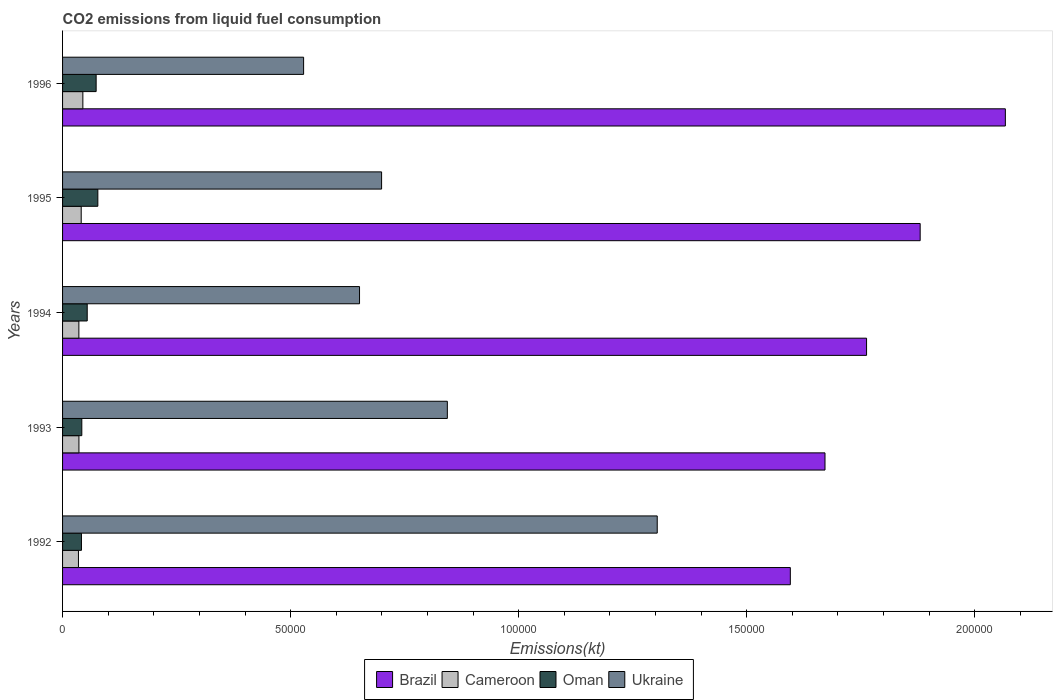How many different coloured bars are there?
Ensure brevity in your answer.  4. How many groups of bars are there?
Provide a short and direct response. 5. Are the number of bars per tick equal to the number of legend labels?
Your answer should be compact. Yes. Are the number of bars on each tick of the Y-axis equal?
Offer a terse response. Yes. In how many cases, is the number of bars for a given year not equal to the number of legend labels?
Make the answer very short. 0. What is the amount of CO2 emitted in Ukraine in 1994?
Provide a short and direct response. 6.51e+04. Across all years, what is the maximum amount of CO2 emitted in Cameroon?
Ensure brevity in your answer.  4448.07. Across all years, what is the minimum amount of CO2 emitted in Cameroon?
Your answer should be compact. 3483.65. In which year was the amount of CO2 emitted in Ukraine minimum?
Provide a short and direct response. 1996. What is the total amount of CO2 emitted in Cameroon in the graph?
Keep it short and to the point. 1.92e+04. What is the difference between the amount of CO2 emitted in Brazil in 1992 and that in 1996?
Your answer should be very brief. -4.71e+04. What is the difference between the amount of CO2 emitted in Oman in 1994 and the amount of CO2 emitted in Cameroon in 1996?
Your answer should be very brief. 957.09. What is the average amount of CO2 emitted in Cameroon per year?
Offer a very short reply. 3836.42. In the year 1993, what is the difference between the amount of CO2 emitted in Ukraine and amount of CO2 emitted in Cameroon?
Your answer should be very brief. 8.08e+04. In how many years, is the amount of CO2 emitted in Ukraine greater than 60000 kt?
Your response must be concise. 4. What is the ratio of the amount of CO2 emitted in Ukraine in 1995 to that in 1996?
Give a very brief answer. 1.32. Is the difference between the amount of CO2 emitted in Ukraine in 1994 and 1996 greater than the difference between the amount of CO2 emitted in Cameroon in 1994 and 1996?
Offer a very short reply. Yes. What is the difference between the highest and the second highest amount of CO2 emitted in Ukraine?
Make the answer very short. 4.60e+04. What is the difference between the highest and the lowest amount of CO2 emitted in Ukraine?
Offer a very short reply. 7.75e+04. In how many years, is the amount of CO2 emitted in Ukraine greater than the average amount of CO2 emitted in Ukraine taken over all years?
Give a very brief answer. 2. Is the sum of the amount of CO2 emitted in Oman in 1993 and 1995 greater than the maximum amount of CO2 emitted in Cameroon across all years?
Your response must be concise. Yes. Is it the case that in every year, the sum of the amount of CO2 emitted in Oman and amount of CO2 emitted in Cameroon is greater than the sum of amount of CO2 emitted in Ukraine and amount of CO2 emitted in Brazil?
Your answer should be compact. No. What does the 2nd bar from the top in 1992 represents?
Offer a terse response. Oman. What does the 3rd bar from the bottom in 1994 represents?
Your answer should be very brief. Oman. Is it the case that in every year, the sum of the amount of CO2 emitted in Oman and amount of CO2 emitted in Ukraine is greater than the amount of CO2 emitted in Cameroon?
Offer a terse response. Yes. How many years are there in the graph?
Your answer should be compact. 5. What is the difference between two consecutive major ticks on the X-axis?
Provide a short and direct response. 5.00e+04. Are the values on the major ticks of X-axis written in scientific E-notation?
Your answer should be compact. No. Does the graph contain any zero values?
Offer a terse response. No. Does the graph contain grids?
Your answer should be compact. No. Where does the legend appear in the graph?
Offer a very short reply. Bottom center. How are the legend labels stacked?
Provide a short and direct response. Horizontal. What is the title of the graph?
Give a very brief answer. CO2 emissions from liquid fuel consumption. Does "Chile" appear as one of the legend labels in the graph?
Offer a terse response. No. What is the label or title of the X-axis?
Offer a very short reply. Emissions(kt). What is the Emissions(kt) of Brazil in 1992?
Provide a succinct answer. 1.60e+05. What is the Emissions(kt) of Cameroon in 1992?
Give a very brief answer. 3483.65. What is the Emissions(kt) of Oman in 1992?
Offer a very short reply. 4140.04. What is the Emissions(kt) of Ukraine in 1992?
Provide a short and direct response. 1.30e+05. What is the Emissions(kt) of Brazil in 1993?
Provide a succinct answer. 1.67e+05. What is the Emissions(kt) in Cameroon in 1993?
Your response must be concise. 3589.99. What is the Emissions(kt) of Oman in 1993?
Provide a succinct answer. 4220.72. What is the Emissions(kt) of Ukraine in 1993?
Your answer should be compact. 8.44e+04. What is the Emissions(kt) in Brazil in 1994?
Keep it short and to the point. 1.76e+05. What is the Emissions(kt) in Cameroon in 1994?
Your answer should be very brief. 3575.32. What is the Emissions(kt) of Oman in 1994?
Offer a very short reply. 5405.16. What is the Emissions(kt) in Ukraine in 1994?
Ensure brevity in your answer.  6.51e+04. What is the Emissions(kt) in Brazil in 1995?
Your response must be concise. 1.88e+05. What is the Emissions(kt) in Cameroon in 1995?
Keep it short and to the point. 4085.04. What is the Emissions(kt) of Oman in 1995?
Provide a short and direct response. 7733.7. What is the Emissions(kt) of Ukraine in 1995?
Offer a terse response. 7.00e+04. What is the Emissions(kt) of Brazil in 1996?
Give a very brief answer. 2.07e+05. What is the Emissions(kt) in Cameroon in 1996?
Ensure brevity in your answer.  4448.07. What is the Emissions(kt) of Oman in 1996?
Offer a very short reply. 7363.34. What is the Emissions(kt) in Ukraine in 1996?
Your answer should be compact. 5.29e+04. Across all years, what is the maximum Emissions(kt) of Brazil?
Offer a very short reply. 2.07e+05. Across all years, what is the maximum Emissions(kt) in Cameroon?
Your response must be concise. 4448.07. Across all years, what is the maximum Emissions(kt) in Oman?
Give a very brief answer. 7733.7. Across all years, what is the maximum Emissions(kt) in Ukraine?
Give a very brief answer. 1.30e+05. Across all years, what is the minimum Emissions(kt) of Brazil?
Provide a short and direct response. 1.60e+05. Across all years, what is the minimum Emissions(kt) of Cameroon?
Offer a very short reply. 3483.65. Across all years, what is the minimum Emissions(kt) of Oman?
Keep it short and to the point. 4140.04. Across all years, what is the minimum Emissions(kt) in Ukraine?
Provide a succinct answer. 5.29e+04. What is the total Emissions(kt) in Brazil in the graph?
Provide a succinct answer. 8.98e+05. What is the total Emissions(kt) in Cameroon in the graph?
Provide a succinct answer. 1.92e+04. What is the total Emissions(kt) of Oman in the graph?
Make the answer very short. 2.89e+04. What is the total Emissions(kt) in Ukraine in the graph?
Offer a terse response. 4.03e+05. What is the difference between the Emissions(kt) in Brazil in 1992 and that in 1993?
Your response must be concise. -7601.69. What is the difference between the Emissions(kt) in Cameroon in 1992 and that in 1993?
Your answer should be very brief. -106.34. What is the difference between the Emissions(kt) of Oman in 1992 and that in 1993?
Make the answer very short. -80.67. What is the difference between the Emissions(kt) of Ukraine in 1992 and that in 1993?
Offer a very short reply. 4.60e+04. What is the difference between the Emissions(kt) in Brazil in 1992 and that in 1994?
Your answer should be compact. -1.67e+04. What is the difference between the Emissions(kt) of Cameroon in 1992 and that in 1994?
Ensure brevity in your answer.  -91.67. What is the difference between the Emissions(kt) in Oman in 1992 and that in 1994?
Provide a succinct answer. -1265.12. What is the difference between the Emissions(kt) in Ukraine in 1992 and that in 1994?
Keep it short and to the point. 6.53e+04. What is the difference between the Emissions(kt) of Brazil in 1992 and that in 1995?
Give a very brief answer. -2.85e+04. What is the difference between the Emissions(kt) of Cameroon in 1992 and that in 1995?
Offer a very short reply. -601.39. What is the difference between the Emissions(kt) in Oman in 1992 and that in 1995?
Offer a terse response. -3593.66. What is the difference between the Emissions(kt) in Ukraine in 1992 and that in 1995?
Your response must be concise. 6.04e+04. What is the difference between the Emissions(kt) in Brazil in 1992 and that in 1996?
Offer a terse response. -4.71e+04. What is the difference between the Emissions(kt) in Cameroon in 1992 and that in 1996?
Ensure brevity in your answer.  -964.42. What is the difference between the Emissions(kt) of Oman in 1992 and that in 1996?
Keep it short and to the point. -3223.29. What is the difference between the Emissions(kt) of Ukraine in 1992 and that in 1996?
Keep it short and to the point. 7.75e+04. What is the difference between the Emissions(kt) in Brazil in 1993 and that in 1994?
Your answer should be compact. -9112.5. What is the difference between the Emissions(kt) of Cameroon in 1993 and that in 1994?
Provide a short and direct response. 14.67. What is the difference between the Emissions(kt) of Oman in 1993 and that in 1994?
Provide a succinct answer. -1184.44. What is the difference between the Emissions(kt) of Ukraine in 1993 and that in 1994?
Your response must be concise. 1.93e+04. What is the difference between the Emissions(kt) of Brazil in 1993 and that in 1995?
Keep it short and to the point. -2.09e+04. What is the difference between the Emissions(kt) of Cameroon in 1993 and that in 1995?
Your answer should be very brief. -495.05. What is the difference between the Emissions(kt) in Oman in 1993 and that in 1995?
Your answer should be very brief. -3512.99. What is the difference between the Emissions(kt) of Ukraine in 1993 and that in 1995?
Give a very brief answer. 1.44e+04. What is the difference between the Emissions(kt) of Brazil in 1993 and that in 1996?
Provide a succinct answer. -3.95e+04. What is the difference between the Emissions(kt) in Cameroon in 1993 and that in 1996?
Your answer should be very brief. -858.08. What is the difference between the Emissions(kt) in Oman in 1993 and that in 1996?
Offer a terse response. -3142.62. What is the difference between the Emissions(kt) in Ukraine in 1993 and that in 1996?
Offer a very short reply. 3.15e+04. What is the difference between the Emissions(kt) in Brazil in 1994 and that in 1995?
Your response must be concise. -1.18e+04. What is the difference between the Emissions(kt) in Cameroon in 1994 and that in 1995?
Offer a very short reply. -509.71. What is the difference between the Emissions(kt) of Oman in 1994 and that in 1995?
Make the answer very short. -2328.55. What is the difference between the Emissions(kt) of Ukraine in 1994 and that in 1995?
Make the answer very short. -4836.77. What is the difference between the Emissions(kt) of Brazil in 1994 and that in 1996?
Ensure brevity in your answer.  -3.04e+04. What is the difference between the Emissions(kt) in Cameroon in 1994 and that in 1996?
Give a very brief answer. -872.75. What is the difference between the Emissions(kt) of Oman in 1994 and that in 1996?
Keep it short and to the point. -1958.18. What is the difference between the Emissions(kt) in Ukraine in 1994 and that in 1996?
Your response must be concise. 1.23e+04. What is the difference between the Emissions(kt) in Brazil in 1995 and that in 1996?
Give a very brief answer. -1.87e+04. What is the difference between the Emissions(kt) of Cameroon in 1995 and that in 1996?
Provide a short and direct response. -363.03. What is the difference between the Emissions(kt) in Oman in 1995 and that in 1996?
Keep it short and to the point. 370.37. What is the difference between the Emissions(kt) of Ukraine in 1995 and that in 1996?
Provide a short and direct response. 1.71e+04. What is the difference between the Emissions(kt) of Brazil in 1992 and the Emissions(kt) of Cameroon in 1993?
Your answer should be compact. 1.56e+05. What is the difference between the Emissions(kt) in Brazil in 1992 and the Emissions(kt) in Oman in 1993?
Provide a short and direct response. 1.55e+05. What is the difference between the Emissions(kt) of Brazil in 1992 and the Emissions(kt) of Ukraine in 1993?
Your answer should be very brief. 7.52e+04. What is the difference between the Emissions(kt) of Cameroon in 1992 and the Emissions(kt) of Oman in 1993?
Keep it short and to the point. -737.07. What is the difference between the Emissions(kt) in Cameroon in 1992 and the Emissions(kt) in Ukraine in 1993?
Offer a terse response. -8.09e+04. What is the difference between the Emissions(kt) in Oman in 1992 and the Emissions(kt) in Ukraine in 1993?
Provide a short and direct response. -8.02e+04. What is the difference between the Emissions(kt) of Brazil in 1992 and the Emissions(kt) of Cameroon in 1994?
Your response must be concise. 1.56e+05. What is the difference between the Emissions(kt) of Brazil in 1992 and the Emissions(kt) of Oman in 1994?
Offer a very short reply. 1.54e+05. What is the difference between the Emissions(kt) of Brazil in 1992 and the Emissions(kt) of Ukraine in 1994?
Make the answer very short. 9.45e+04. What is the difference between the Emissions(kt) in Cameroon in 1992 and the Emissions(kt) in Oman in 1994?
Provide a short and direct response. -1921.51. What is the difference between the Emissions(kt) of Cameroon in 1992 and the Emissions(kt) of Ukraine in 1994?
Provide a succinct answer. -6.16e+04. What is the difference between the Emissions(kt) of Oman in 1992 and the Emissions(kt) of Ukraine in 1994?
Provide a succinct answer. -6.10e+04. What is the difference between the Emissions(kt) of Brazil in 1992 and the Emissions(kt) of Cameroon in 1995?
Offer a terse response. 1.55e+05. What is the difference between the Emissions(kt) of Brazil in 1992 and the Emissions(kt) of Oman in 1995?
Offer a very short reply. 1.52e+05. What is the difference between the Emissions(kt) of Brazil in 1992 and the Emissions(kt) of Ukraine in 1995?
Provide a short and direct response. 8.96e+04. What is the difference between the Emissions(kt) in Cameroon in 1992 and the Emissions(kt) in Oman in 1995?
Offer a terse response. -4250.05. What is the difference between the Emissions(kt) in Cameroon in 1992 and the Emissions(kt) in Ukraine in 1995?
Offer a very short reply. -6.65e+04. What is the difference between the Emissions(kt) of Oman in 1992 and the Emissions(kt) of Ukraine in 1995?
Keep it short and to the point. -6.58e+04. What is the difference between the Emissions(kt) in Brazil in 1992 and the Emissions(kt) in Cameroon in 1996?
Offer a terse response. 1.55e+05. What is the difference between the Emissions(kt) of Brazil in 1992 and the Emissions(kt) of Oman in 1996?
Make the answer very short. 1.52e+05. What is the difference between the Emissions(kt) of Brazil in 1992 and the Emissions(kt) of Ukraine in 1996?
Offer a terse response. 1.07e+05. What is the difference between the Emissions(kt) in Cameroon in 1992 and the Emissions(kt) in Oman in 1996?
Your response must be concise. -3879.69. What is the difference between the Emissions(kt) in Cameroon in 1992 and the Emissions(kt) in Ukraine in 1996?
Your answer should be very brief. -4.94e+04. What is the difference between the Emissions(kt) in Oman in 1992 and the Emissions(kt) in Ukraine in 1996?
Ensure brevity in your answer.  -4.87e+04. What is the difference between the Emissions(kt) of Brazil in 1993 and the Emissions(kt) of Cameroon in 1994?
Offer a very short reply. 1.64e+05. What is the difference between the Emissions(kt) of Brazil in 1993 and the Emissions(kt) of Oman in 1994?
Offer a very short reply. 1.62e+05. What is the difference between the Emissions(kt) in Brazil in 1993 and the Emissions(kt) in Ukraine in 1994?
Offer a very short reply. 1.02e+05. What is the difference between the Emissions(kt) of Cameroon in 1993 and the Emissions(kt) of Oman in 1994?
Your answer should be very brief. -1815.16. What is the difference between the Emissions(kt) in Cameroon in 1993 and the Emissions(kt) in Ukraine in 1994?
Offer a very short reply. -6.15e+04. What is the difference between the Emissions(kt) of Oman in 1993 and the Emissions(kt) of Ukraine in 1994?
Ensure brevity in your answer.  -6.09e+04. What is the difference between the Emissions(kt) in Brazil in 1993 and the Emissions(kt) in Cameroon in 1995?
Give a very brief answer. 1.63e+05. What is the difference between the Emissions(kt) in Brazil in 1993 and the Emissions(kt) in Oman in 1995?
Keep it short and to the point. 1.59e+05. What is the difference between the Emissions(kt) of Brazil in 1993 and the Emissions(kt) of Ukraine in 1995?
Keep it short and to the point. 9.72e+04. What is the difference between the Emissions(kt) of Cameroon in 1993 and the Emissions(kt) of Oman in 1995?
Provide a succinct answer. -4143.71. What is the difference between the Emissions(kt) of Cameroon in 1993 and the Emissions(kt) of Ukraine in 1995?
Make the answer very short. -6.64e+04. What is the difference between the Emissions(kt) of Oman in 1993 and the Emissions(kt) of Ukraine in 1995?
Give a very brief answer. -6.57e+04. What is the difference between the Emissions(kt) in Brazil in 1993 and the Emissions(kt) in Cameroon in 1996?
Make the answer very short. 1.63e+05. What is the difference between the Emissions(kt) in Brazil in 1993 and the Emissions(kt) in Oman in 1996?
Keep it short and to the point. 1.60e+05. What is the difference between the Emissions(kt) in Brazil in 1993 and the Emissions(kt) in Ukraine in 1996?
Make the answer very short. 1.14e+05. What is the difference between the Emissions(kt) in Cameroon in 1993 and the Emissions(kt) in Oman in 1996?
Offer a terse response. -3773.34. What is the difference between the Emissions(kt) in Cameroon in 1993 and the Emissions(kt) in Ukraine in 1996?
Your answer should be compact. -4.93e+04. What is the difference between the Emissions(kt) in Oman in 1993 and the Emissions(kt) in Ukraine in 1996?
Your response must be concise. -4.86e+04. What is the difference between the Emissions(kt) of Brazil in 1994 and the Emissions(kt) of Cameroon in 1995?
Your response must be concise. 1.72e+05. What is the difference between the Emissions(kt) of Brazil in 1994 and the Emissions(kt) of Oman in 1995?
Your answer should be very brief. 1.69e+05. What is the difference between the Emissions(kt) of Brazil in 1994 and the Emissions(kt) of Ukraine in 1995?
Make the answer very short. 1.06e+05. What is the difference between the Emissions(kt) in Cameroon in 1994 and the Emissions(kt) in Oman in 1995?
Give a very brief answer. -4158.38. What is the difference between the Emissions(kt) in Cameroon in 1994 and the Emissions(kt) in Ukraine in 1995?
Your answer should be compact. -6.64e+04. What is the difference between the Emissions(kt) in Oman in 1994 and the Emissions(kt) in Ukraine in 1995?
Make the answer very short. -6.45e+04. What is the difference between the Emissions(kt) of Brazil in 1994 and the Emissions(kt) of Cameroon in 1996?
Offer a terse response. 1.72e+05. What is the difference between the Emissions(kt) of Brazil in 1994 and the Emissions(kt) of Oman in 1996?
Offer a very short reply. 1.69e+05. What is the difference between the Emissions(kt) of Brazil in 1994 and the Emissions(kt) of Ukraine in 1996?
Ensure brevity in your answer.  1.23e+05. What is the difference between the Emissions(kt) of Cameroon in 1994 and the Emissions(kt) of Oman in 1996?
Your answer should be very brief. -3788.01. What is the difference between the Emissions(kt) of Cameroon in 1994 and the Emissions(kt) of Ukraine in 1996?
Your answer should be very brief. -4.93e+04. What is the difference between the Emissions(kt) in Oman in 1994 and the Emissions(kt) in Ukraine in 1996?
Provide a short and direct response. -4.74e+04. What is the difference between the Emissions(kt) of Brazil in 1995 and the Emissions(kt) of Cameroon in 1996?
Offer a terse response. 1.84e+05. What is the difference between the Emissions(kt) of Brazil in 1995 and the Emissions(kt) of Oman in 1996?
Keep it short and to the point. 1.81e+05. What is the difference between the Emissions(kt) in Brazil in 1995 and the Emissions(kt) in Ukraine in 1996?
Give a very brief answer. 1.35e+05. What is the difference between the Emissions(kt) in Cameroon in 1995 and the Emissions(kt) in Oman in 1996?
Ensure brevity in your answer.  -3278.3. What is the difference between the Emissions(kt) of Cameroon in 1995 and the Emissions(kt) of Ukraine in 1996?
Offer a very short reply. -4.88e+04. What is the difference between the Emissions(kt) of Oman in 1995 and the Emissions(kt) of Ukraine in 1996?
Make the answer very short. -4.51e+04. What is the average Emissions(kt) in Brazil per year?
Your answer should be compact. 1.80e+05. What is the average Emissions(kt) in Cameroon per year?
Your response must be concise. 3836.42. What is the average Emissions(kt) of Oman per year?
Your answer should be compact. 5772.59. What is the average Emissions(kt) in Ukraine per year?
Ensure brevity in your answer.  8.05e+04. In the year 1992, what is the difference between the Emissions(kt) of Brazil and Emissions(kt) of Cameroon?
Your response must be concise. 1.56e+05. In the year 1992, what is the difference between the Emissions(kt) of Brazil and Emissions(kt) of Oman?
Keep it short and to the point. 1.55e+05. In the year 1992, what is the difference between the Emissions(kt) in Brazil and Emissions(kt) in Ukraine?
Your answer should be very brief. 2.92e+04. In the year 1992, what is the difference between the Emissions(kt) in Cameroon and Emissions(kt) in Oman?
Offer a terse response. -656.39. In the year 1992, what is the difference between the Emissions(kt) of Cameroon and Emissions(kt) of Ukraine?
Offer a very short reply. -1.27e+05. In the year 1992, what is the difference between the Emissions(kt) in Oman and Emissions(kt) in Ukraine?
Provide a short and direct response. -1.26e+05. In the year 1993, what is the difference between the Emissions(kt) of Brazil and Emissions(kt) of Cameroon?
Provide a succinct answer. 1.64e+05. In the year 1993, what is the difference between the Emissions(kt) of Brazil and Emissions(kt) of Oman?
Your answer should be compact. 1.63e+05. In the year 1993, what is the difference between the Emissions(kt) of Brazil and Emissions(kt) of Ukraine?
Make the answer very short. 8.28e+04. In the year 1993, what is the difference between the Emissions(kt) in Cameroon and Emissions(kt) in Oman?
Keep it short and to the point. -630.72. In the year 1993, what is the difference between the Emissions(kt) of Cameroon and Emissions(kt) of Ukraine?
Keep it short and to the point. -8.08e+04. In the year 1993, what is the difference between the Emissions(kt) of Oman and Emissions(kt) of Ukraine?
Keep it short and to the point. -8.01e+04. In the year 1994, what is the difference between the Emissions(kt) of Brazil and Emissions(kt) of Cameroon?
Keep it short and to the point. 1.73e+05. In the year 1994, what is the difference between the Emissions(kt) of Brazil and Emissions(kt) of Oman?
Give a very brief answer. 1.71e+05. In the year 1994, what is the difference between the Emissions(kt) in Brazil and Emissions(kt) in Ukraine?
Offer a terse response. 1.11e+05. In the year 1994, what is the difference between the Emissions(kt) in Cameroon and Emissions(kt) in Oman?
Give a very brief answer. -1829.83. In the year 1994, what is the difference between the Emissions(kt) in Cameroon and Emissions(kt) in Ukraine?
Your answer should be compact. -6.15e+04. In the year 1994, what is the difference between the Emissions(kt) in Oman and Emissions(kt) in Ukraine?
Ensure brevity in your answer.  -5.97e+04. In the year 1995, what is the difference between the Emissions(kt) in Brazil and Emissions(kt) in Cameroon?
Keep it short and to the point. 1.84e+05. In the year 1995, what is the difference between the Emissions(kt) in Brazil and Emissions(kt) in Oman?
Make the answer very short. 1.80e+05. In the year 1995, what is the difference between the Emissions(kt) in Brazil and Emissions(kt) in Ukraine?
Your answer should be very brief. 1.18e+05. In the year 1995, what is the difference between the Emissions(kt) of Cameroon and Emissions(kt) of Oman?
Your response must be concise. -3648.66. In the year 1995, what is the difference between the Emissions(kt) of Cameroon and Emissions(kt) of Ukraine?
Your answer should be compact. -6.59e+04. In the year 1995, what is the difference between the Emissions(kt) of Oman and Emissions(kt) of Ukraine?
Provide a short and direct response. -6.22e+04. In the year 1996, what is the difference between the Emissions(kt) of Brazil and Emissions(kt) of Cameroon?
Provide a succinct answer. 2.02e+05. In the year 1996, what is the difference between the Emissions(kt) in Brazil and Emissions(kt) in Oman?
Give a very brief answer. 1.99e+05. In the year 1996, what is the difference between the Emissions(kt) in Brazil and Emissions(kt) in Ukraine?
Provide a succinct answer. 1.54e+05. In the year 1996, what is the difference between the Emissions(kt) of Cameroon and Emissions(kt) of Oman?
Your response must be concise. -2915.26. In the year 1996, what is the difference between the Emissions(kt) in Cameroon and Emissions(kt) in Ukraine?
Offer a terse response. -4.84e+04. In the year 1996, what is the difference between the Emissions(kt) of Oman and Emissions(kt) of Ukraine?
Provide a short and direct response. -4.55e+04. What is the ratio of the Emissions(kt) of Brazil in 1992 to that in 1993?
Ensure brevity in your answer.  0.95. What is the ratio of the Emissions(kt) in Cameroon in 1992 to that in 1993?
Keep it short and to the point. 0.97. What is the ratio of the Emissions(kt) in Oman in 1992 to that in 1993?
Offer a very short reply. 0.98. What is the ratio of the Emissions(kt) of Ukraine in 1992 to that in 1993?
Your answer should be very brief. 1.55. What is the ratio of the Emissions(kt) in Brazil in 1992 to that in 1994?
Your response must be concise. 0.91. What is the ratio of the Emissions(kt) of Cameroon in 1992 to that in 1994?
Your response must be concise. 0.97. What is the ratio of the Emissions(kt) of Oman in 1992 to that in 1994?
Your response must be concise. 0.77. What is the ratio of the Emissions(kt) in Ukraine in 1992 to that in 1994?
Keep it short and to the point. 2. What is the ratio of the Emissions(kt) of Brazil in 1992 to that in 1995?
Your answer should be very brief. 0.85. What is the ratio of the Emissions(kt) in Cameroon in 1992 to that in 1995?
Provide a short and direct response. 0.85. What is the ratio of the Emissions(kt) of Oman in 1992 to that in 1995?
Offer a terse response. 0.54. What is the ratio of the Emissions(kt) of Ukraine in 1992 to that in 1995?
Provide a succinct answer. 1.86. What is the ratio of the Emissions(kt) of Brazil in 1992 to that in 1996?
Offer a terse response. 0.77. What is the ratio of the Emissions(kt) of Cameroon in 1992 to that in 1996?
Your response must be concise. 0.78. What is the ratio of the Emissions(kt) of Oman in 1992 to that in 1996?
Your answer should be compact. 0.56. What is the ratio of the Emissions(kt) in Ukraine in 1992 to that in 1996?
Keep it short and to the point. 2.47. What is the ratio of the Emissions(kt) in Brazil in 1993 to that in 1994?
Your answer should be compact. 0.95. What is the ratio of the Emissions(kt) of Cameroon in 1993 to that in 1994?
Give a very brief answer. 1. What is the ratio of the Emissions(kt) of Oman in 1993 to that in 1994?
Provide a short and direct response. 0.78. What is the ratio of the Emissions(kt) in Ukraine in 1993 to that in 1994?
Offer a very short reply. 1.3. What is the ratio of the Emissions(kt) of Brazil in 1993 to that in 1995?
Your answer should be compact. 0.89. What is the ratio of the Emissions(kt) of Cameroon in 1993 to that in 1995?
Provide a succinct answer. 0.88. What is the ratio of the Emissions(kt) in Oman in 1993 to that in 1995?
Offer a terse response. 0.55. What is the ratio of the Emissions(kt) in Ukraine in 1993 to that in 1995?
Your response must be concise. 1.21. What is the ratio of the Emissions(kt) in Brazil in 1993 to that in 1996?
Provide a succinct answer. 0.81. What is the ratio of the Emissions(kt) of Cameroon in 1993 to that in 1996?
Your answer should be compact. 0.81. What is the ratio of the Emissions(kt) in Oman in 1993 to that in 1996?
Your answer should be very brief. 0.57. What is the ratio of the Emissions(kt) of Ukraine in 1993 to that in 1996?
Provide a short and direct response. 1.6. What is the ratio of the Emissions(kt) in Brazil in 1994 to that in 1995?
Provide a short and direct response. 0.94. What is the ratio of the Emissions(kt) of Cameroon in 1994 to that in 1995?
Your answer should be very brief. 0.88. What is the ratio of the Emissions(kt) of Oman in 1994 to that in 1995?
Your answer should be compact. 0.7. What is the ratio of the Emissions(kt) of Ukraine in 1994 to that in 1995?
Keep it short and to the point. 0.93. What is the ratio of the Emissions(kt) in Brazil in 1994 to that in 1996?
Your response must be concise. 0.85. What is the ratio of the Emissions(kt) of Cameroon in 1994 to that in 1996?
Offer a very short reply. 0.8. What is the ratio of the Emissions(kt) in Oman in 1994 to that in 1996?
Your answer should be very brief. 0.73. What is the ratio of the Emissions(kt) of Ukraine in 1994 to that in 1996?
Offer a very short reply. 1.23. What is the ratio of the Emissions(kt) of Brazil in 1995 to that in 1996?
Offer a very short reply. 0.91. What is the ratio of the Emissions(kt) in Cameroon in 1995 to that in 1996?
Provide a short and direct response. 0.92. What is the ratio of the Emissions(kt) in Oman in 1995 to that in 1996?
Your response must be concise. 1.05. What is the ratio of the Emissions(kt) in Ukraine in 1995 to that in 1996?
Your answer should be compact. 1.32. What is the difference between the highest and the second highest Emissions(kt) in Brazil?
Offer a very short reply. 1.87e+04. What is the difference between the highest and the second highest Emissions(kt) in Cameroon?
Your answer should be very brief. 363.03. What is the difference between the highest and the second highest Emissions(kt) in Oman?
Keep it short and to the point. 370.37. What is the difference between the highest and the second highest Emissions(kt) of Ukraine?
Ensure brevity in your answer.  4.60e+04. What is the difference between the highest and the lowest Emissions(kt) of Brazil?
Your answer should be very brief. 4.71e+04. What is the difference between the highest and the lowest Emissions(kt) of Cameroon?
Offer a terse response. 964.42. What is the difference between the highest and the lowest Emissions(kt) in Oman?
Provide a succinct answer. 3593.66. What is the difference between the highest and the lowest Emissions(kt) in Ukraine?
Offer a terse response. 7.75e+04. 